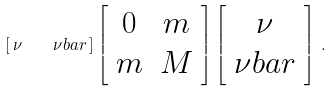Convert formula to latex. <formula><loc_0><loc_0><loc_500><loc_500>\left [ \, \nu \quad \nu b a r \, \right ] \left [ \begin{array} { c c } 0 & m \\ m & M \end{array} \right ] \left [ \begin{array} { c } \nu \\ \nu b a r \end{array} \right ] \, .</formula> 